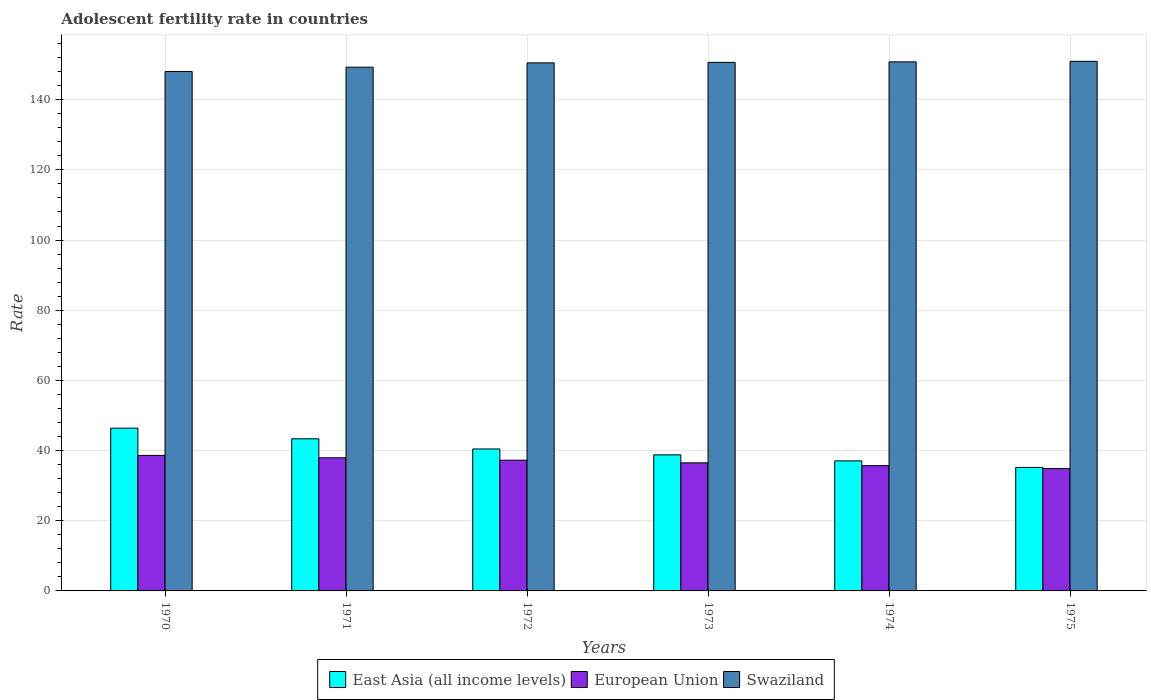How many groups of bars are there?
Keep it short and to the point. 6. Are the number of bars per tick equal to the number of legend labels?
Your answer should be compact. Yes. How many bars are there on the 4th tick from the right?
Your answer should be very brief. 3. What is the label of the 5th group of bars from the left?
Provide a succinct answer. 1974. What is the adolescent fertility rate in European Union in 1973?
Offer a very short reply. 36.5. Across all years, what is the maximum adolescent fertility rate in European Union?
Make the answer very short. 38.62. Across all years, what is the minimum adolescent fertility rate in East Asia (all income levels)?
Give a very brief answer. 35.21. In which year was the adolescent fertility rate in European Union minimum?
Ensure brevity in your answer.  1975. What is the total adolescent fertility rate in European Union in the graph?
Provide a short and direct response. 220.91. What is the difference between the adolescent fertility rate in Swaziland in 1971 and that in 1972?
Offer a very short reply. -1.23. What is the difference between the adolescent fertility rate in East Asia (all income levels) in 1970 and the adolescent fertility rate in European Union in 1971?
Your answer should be very brief. 8.45. What is the average adolescent fertility rate in European Union per year?
Give a very brief answer. 36.82. In the year 1973, what is the difference between the adolescent fertility rate in East Asia (all income levels) and adolescent fertility rate in European Union?
Give a very brief answer. 2.28. In how many years, is the adolescent fertility rate in European Union greater than 112?
Make the answer very short. 0. What is the ratio of the adolescent fertility rate in East Asia (all income levels) in 1970 to that in 1974?
Offer a terse response. 1.25. Is the adolescent fertility rate in Swaziland in 1973 less than that in 1975?
Your response must be concise. Yes. What is the difference between the highest and the second highest adolescent fertility rate in European Union?
Provide a succinct answer. 0.67. What is the difference between the highest and the lowest adolescent fertility rate in East Asia (all income levels)?
Your answer should be compact. 11.19. What does the 1st bar from the left in 1975 represents?
Make the answer very short. East Asia (all income levels). What does the 3rd bar from the right in 1972 represents?
Your response must be concise. East Asia (all income levels). Is it the case that in every year, the sum of the adolescent fertility rate in East Asia (all income levels) and adolescent fertility rate in Swaziland is greater than the adolescent fertility rate in European Union?
Offer a terse response. Yes. How many bars are there?
Provide a short and direct response. 18. What is the difference between two consecutive major ticks on the Y-axis?
Provide a short and direct response. 20. Does the graph contain grids?
Provide a succinct answer. Yes. Where does the legend appear in the graph?
Give a very brief answer. Bottom center. How many legend labels are there?
Provide a short and direct response. 3. What is the title of the graph?
Your answer should be very brief. Adolescent fertility rate in countries. Does "Brazil" appear as one of the legend labels in the graph?
Make the answer very short. No. What is the label or title of the Y-axis?
Provide a short and direct response. Rate. What is the Rate in East Asia (all income levels) in 1970?
Provide a succinct answer. 46.4. What is the Rate of European Union in 1970?
Your answer should be compact. 38.62. What is the Rate in Swaziland in 1970?
Ensure brevity in your answer.  148.05. What is the Rate of East Asia (all income levels) in 1971?
Provide a short and direct response. 43.36. What is the Rate in European Union in 1971?
Your answer should be very brief. 37.94. What is the Rate of Swaziland in 1971?
Make the answer very short. 149.28. What is the Rate of East Asia (all income levels) in 1972?
Give a very brief answer. 40.46. What is the Rate in European Union in 1972?
Provide a short and direct response. 37.26. What is the Rate of Swaziland in 1972?
Keep it short and to the point. 150.5. What is the Rate of East Asia (all income levels) in 1973?
Offer a terse response. 38.78. What is the Rate of European Union in 1973?
Provide a succinct answer. 36.5. What is the Rate of Swaziland in 1973?
Make the answer very short. 150.65. What is the Rate of East Asia (all income levels) in 1974?
Keep it short and to the point. 37.06. What is the Rate in European Union in 1974?
Make the answer very short. 35.71. What is the Rate in Swaziland in 1974?
Keep it short and to the point. 150.79. What is the Rate in East Asia (all income levels) in 1975?
Give a very brief answer. 35.21. What is the Rate of European Union in 1975?
Give a very brief answer. 34.88. What is the Rate of Swaziland in 1975?
Your response must be concise. 150.94. Across all years, what is the maximum Rate in East Asia (all income levels)?
Your response must be concise. 46.4. Across all years, what is the maximum Rate in European Union?
Make the answer very short. 38.62. Across all years, what is the maximum Rate in Swaziland?
Keep it short and to the point. 150.94. Across all years, what is the minimum Rate of East Asia (all income levels)?
Your answer should be very brief. 35.21. Across all years, what is the minimum Rate in European Union?
Ensure brevity in your answer.  34.88. Across all years, what is the minimum Rate of Swaziland?
Your answer should be very brief. 148.05. What is the total Rate of East Asia (all income levels) in the graph?
Give a very brief answer. 241.27. What is the total Rate of European Union in the graph?
Give a very brief answer. 220.91. What is the total Rate in Swaziland in the graph?
Your response must be concise. 900.2. What is the difference between the Rate in East Asia (all income levels) in 1970 and that in 1971?
Your response must be concise. 3.04. What is the difference between the Rate of European Union in 1970 and that in 1971?
Ensure brevity in your answer.  0.67. What is the difference between the Rate of Swaziland in 1970 and that in 1971?
Your answer should be compact. -1.23. What is the difference between the Rate in East Asia (all income levels) in 1970 and that in 1972?
Provide a succinct answer. 5.94. What is the difference between the Rate in European Union in 1970 and that in 1972?
Keep it short and to the point. 1.36. What is the difference between the Rate of Swaziland in 1970 and that in 1972?
Give a very brief answer. -2.46. What is the difference between the Rate of East Asia (all income levels) in 1970 and that in 1973?
Offer a terse response. 7.62. What is the difference between the Rate of European Union in 1970 and that in 1973?
Give a very brief answer. 2.11. What is the difference between the Rate of East Asia (all income levels) in 1970 and that in 1974?
Offer a very short reply. 9.34. What is the difference between the Rate of European Union in 1970 and that in 1974?
Make the answer very short. 2.9. What is the difference between the Rate in Swaziland in 1970 and that in 1974?
Offer a terse response. -2.74. What is the difference between the Rate of East Asia (all income levels) in 1970 and that in 1975?
Keep it short and to the point. 11.19. What is the difference between the Rate of European Union in 1970 and that in 1975?
Provide a succinct answer. 3.74. What is the difference between the Rate of Swaziland in 1970 and that in 1975?
Give a very brief answer. -2.89. What is the difference between the Rate in East Asia (all income levels) in 1971 and that in 1972?
Make the answer very short. 2.9. What is the difference between the Rate in European Union in 1971 and that in 1972?
Offer a terse response. 0.69. What is the difference between the Rate in Swaziland in 1971 and that in 1972?
Offer a very short reply. -1.23. What is the difference between the Rate of East Asia (all income levels) in 1971 and that in 1973?
Your answer should be very brief. 4.58. What is the difference between the Rate of European Union in 1971 and that in 1973?
Offer a very short reply. 1.44. What is the difference between the Rate of Swaziland in 1971 and that in 1973?
Make the answer very short. -1.37. What is the difference between the Rate in East Asia (all income levels) in 1971 and that in 1974?
Provide a succinct answer. 6.3. What is the difference between the Rate in European Union in 1971 and that in 1974?
Keep it short and to the point. 2.23. What is the difference between the Rate of Swaziland in 1971 and that in 1974?
Ensure brevity in your answer.  -1.52. What is the difference between the Rate in East Asia (all income levels) in 1971 and that in 1975?
Your answer should be compact. 8.15. What is the difference between the Rate in European Union in 1971 and that in 1975?
Provide a succinct answer. 3.06. What is the difference between the Rate in Swaziland in 1971 and that in 1975?
Give a very brief answer. -1.66. What is the difference between the Rate in East Asia (all income levels) in 1972 and that in 1973?
Keep it short and to the point. 1.68. What is the difference between the Rate in European Union in 1972 and that in 1973?
Make the answer very short. 0.75. What is the difference between the Rate of Swaziland in 1972 and that in 1973?
Ensure brevity in your answer.  -0.14. What is the difference between the Rate in East Asia (all income levels) in 1972 and that in 1974?
Your response must be concise. 3.4. What is the difference between the Rate in European Union in 1972 and that in 1974?
Offer a very short reply. 1.54. What is the difference between the Rate of Swaziland in 1972 and that in 1974?
Offer a very short reply. -0.29. What is the difference between the Rate in East Asia (all income levels) in 1972 and that in 1975?
Provide a succinct answer. 5.25. What is the difference between the Rate of European Union in 1972 and that in 1975?
Offer a very short reply. 2.38. What is the difference between the Rate of Swaziland in 1972 and that in 1975?
Make the answer very short. -0.43. What is the difference between the Rate of East Asia (all income levels) in 1973 and that in 1974?
Offer a terse response. 1.72. What is the difference between the Rate in European Union in 1973 and that in 1974?
Your answer should be compact. 0.79. What is the difference between the Rate in Swaziland in 1973 and that in 1974?
Make the answer very short. -0.14. What is the difference between the Rate in East Asia (all income levels) in 1973 and that in 1975?
Offer a very short reply. 3.57. What is the difference between the Rate in European Union in 1973 and that in 1975?
Offer a terse response. 1.62. What is the difference between the Rate in Swaziland in 1973 and that in 1975?
Provide a succinct answer. -0.29. What is the difference between the Rate in East Asia (all income levels) in 1974 and that in 1975?
Ensure brevity in your answer.  1.85. What is the difference between the Rate of European Union in 1974 and that in 1975?
Give a very brief answer. 0.83. What is the difference between the Rate in Swaziland in 1974 and that in 1975?
Your answer should be very brief. -0.14. What is the difference between the Rate of East Asia (all income levels) in 1970 and the Rate of European Union in 1971?
Your answer should be very brief. 8.45. What is the difference between the Rate of East Asia (all income levels) in 1970 and the Rate of Swaziland in 1971?
Keep it short and to the point. -102.88. What is the difference between the Rate of European Union in 1970 and the Rate of Swaziland in 1971?
Make the answer very short. -110.66. What is the difference between the Rate of East Asia (all income levels) in 1970 and the Rate of European Union in 1972?
Your answer should be very brief. 9.14. What is the difference between the Rate in East Asia (all income levels) in 1970 and the Rate in Swaziland in 1972?
Your response must be concise. -104.1. What is the difference between the Rate of European Union in 1970 and the Rate of Swaziland in 1972?
Give a very brief answer. -111.89. What is the difference between the Rate of East Asia (all income levels) in 1970 and the Rate of European Union in 1973?
Your answer should be very brief. 9.9. What is the difference between the Rate in East Asia (all income levels) in 1970 and the Rate in Swaziland in 1973?
Offer a very short reply. -104.25. What is the difference between the Rate in European Union in 1970 and the Rate in Swaziland in 1973?
Ensure brevity in your answer.  -112.03. What is the difference between the Rate of East Asia (all income levels) in 1970 and the Rate of European Union in 1974?
Your response must be concise. 10.69. What is the difference between the Rate of East Asia (all income levels) in 1970 and the Rate of Swaziland in 1974?
Offer a very short reply. -104.39. What is the difference between the Rate in European Union in 1970 and the Rate in Swaziland in 1974?
Ensure brevity in your answer.  -112.18. What is the difference between the Rate of East Asia (all income levels) in 1970 and the Rate of European Union in 1975?
Your answer should be very brief. 11.52. What is the difference between the Rate of East Asia (all income levels) in 1970 and the Rate of Swaziland in 1975?
Offer a terse response. -104.54. What is the difference between the Rate of European Union in 1970 and the Rate of Swaziland in 1975?
Provide a short and direct response. -112.32. What is the difference between the Rate of East Asia (all income levels) in 1971 and the Rate of European Union in 1972?
Give a very brief answer. 6.11. What is the difference between the Rate in East Asia (all income levels) in 1971 and the Rate in Swaziland in 1972?
Your answer should be very brief. -107.14. What is the difference between the Rate of European Union in 1971 and the Rate of Swaziland in 1972?
Provide a short and direct response. -112.56. What is the difference between the Rate of East Asia (all income levels) in 1971 and the Rate of European Union in 1973?
Offer a very short reply. 6.86. What is the difference between the Rate of East Asia (all income levels) in 1971 and the Rate of Swaziland in 1973?
Your answer should be very brief. -107.28. What is the difference between the Rate of European Union in 1971 and the Rate of Swaziland in 1973?
Make the answer very short. -112.7. What is the difference between the Rate in East Asia (all income levels) in 1971 and the Rate in European Union in 1974?
Ensure brevity in your answer.  7.65. What is the difference between the Rate in East Asia (all income levels) in 1971 and the Rate in Swaziland in 1974?
Your answer should be very brief. -107.43. What is the difference between the Rate in European Union in 1971 and the Rate in Swaziland in 1974?
Provide a short and direct response. -112.85. What is the difference between the Rate in East Asia (all income levels) in 1971 and the Rate in European Union in 1975?
Keep it short and to the point. 8.48. What is the difference between the Rate of East Asia (all income levels) in 1971 and the Rate of Swaziland in 1975?
Make the answer very short. -107.57. What is the difference between the Rate in European Union in 1971 and the Rate in Swaziland in 1975?
Offer a terse response. -112.99. What is the difference between the Rate of East Asia (all income levels) in 1972 and the Rate of European Union in 1973?
Make the answer very short. 3.96. What is the difference between the Rate of East Asia (all income levels) in 1972 and the Rate of Swaziland in 1973?
Provide a short and direct response. -110.19. What is the difference between the Rate in European Union in 1972 and the Rate in Swaziland in 1973?
Provide a short and direct response. -113.39. What is the difference between the Rate of East Asia (all income levels) in 1972 and the Rate of European Union in 1974?
Ensure brevity in your answer.  4.75. What is the difference between the Rate in East Asia (all income levels) in 1972 and the Rate in Swaziland in 1974?
Your answer should be very brief. -110.33. What is the difference between the Rate in European Union in 1972 and the Rate in Swaziland in 1974?
Your answer should be compact. -113.54. What is the difference between the Rate in East Asia (all income levels) in 1972 and the Rate in European Union in 1975?
Ensure brevity in your answer.  5.58. What is the difference between the Rate in East Asia (all income levels) in 1972 and the Rate in Swaziland in 1975?
Provide a succinct answer. -110.48. What is the difference between the Rate of European Union in 1972 and the Rate of Swaziland in 1975?
Provide a succinct answer. -113.68. What is the difference between the Rate in East Asia (all income levels) in 1973 and the Rate in European Union in 1974?
Provide a short and direct response. 3.07. What is the difference between the Rate of East Asia (all income levels) in 1973 and the Rate of Swaziland in 1974?
Give a very brief answer. -112.01. What is the difference between the Rate of European Union in 1973 and the Rate of Swaziland in 1974?
Your answer should be compact. -114.29. What is the difference between the Rate in East Asia (all income levels) in 1973 and the Rate in European Union in 1975?
Make the answer very short. 3.9. What is the difference between the Rate in East Asia (all income levels) in 1973 and the Rate in Swaziland in 1975?
Offer a very short reply. -112.16. What is the difference between the Rate of European Union in 1973 and the Rate of Swaziland in 1975?
Your response must be concise. -114.43. What is the difference between the Rate in East Asia (all income levels) in 1974 and the Rate in European Union in 1975?
Make the answer very short. 2.18. What is the difference between the Rate of East Asia (all income levels) in 1974 and the Rate of Swaziland in 1975?
Your answer should be very brief. -113.88. What is the difference between the Rate in European Union in 1974 and the Rate in Swaziland in 1975?
Make the answer very short. -115.22. What is the average Rate in East Asia (all income levels) per year?
Offer a terse response. 40.21. What is the average Rate in European Union per year?
Offer a very short reply. 36.82. What is the average Rate in Swaziland per year?
Your answer should be compact. 150.03. In the year 1970, what is the difference between the Rate in East Asia (all income levels) and Rate in European Union?
Offer a terse response. 7.78. In the year 1970, what is the difference between the Rate of East Asia (all income levels) and Rate of Swaziland?
Your response must be concise. -101.65. In the year 1970, what is the difference between the Rate of European Union and Rate of Swaziland?
Give a very brief answer. -109.43. In the year 1971, what is the difference between the Rate in East Asia (all income levels) and Rate in European Union?
Your response must be concise. 5.42. In the year 1971, what is the difference between the Rate in East Asia (all income levels) and Rate in Swaziland?
Offer a very short reply. -105.91. In the year 1971, what is the difference between the Rate of European Union and Rate of Swaziland?
Provide a succinct answer. -111.33. In the year 1972, what is the difference between the Rate in East Asia (all income levels) and Rate in European Union?
Your answer should be very brief. 3.2. In the year 1972, what is the difference between the Rate in East Asia (all income levels) and Rate in Swaziland?
Ensure brevity in your answer.  -110.04. In the year 1972, what is the difference between the Rate in European Union and Rate in Swaziland?
Make the answer very short. -113.25. In the year 1973, what is the difference between the Rate of East Asia (all income levels) and Rate of European Union?
Offer a very short reply. 2.28. In the year 1973, what is the difference between the Rate in East Asia (all income levels) and Rate in Swaziland?
Make the answer very short. -111.87. In the year 1973, what is the difference between the Rate of European Union and Rate of Swaziland?
Give a very brief answer. -114.14. In the year 1974, what is the difference between the Rate of East Asia (all income levels) and Rate of European Union?
Keep it short and to the point. 1.35. In the year 1974, what is the difference between the Rate in East Asia (all income levels) and Rate in Swaziland?
Your answer should be compact. -113.73. In the year 1974, what is the difference between the Rate in European Union and Rate in Swaziland?
Your response must be concise. -115.08. In the year 1975, what is the difference between the Rate in East Asia (all income levels) and Rate in European Union?
Give a very brief answer. 0.33. In the year 1975, what is the difference between the Rate of East Asia (all income levels) and Rate of Swaziland?
Offer a terse response. -115.73. In the year 1975, what is the difference between the Rate in European Union and Rate in Swaziland?
Give a very brief answer. -116.06. What is the ratio of the Rate of East Asia (all income levels) in 1970 to that in 1971?
Offer a terse response. 1.07. What is the ratio of the Rate of European Union in 1970 to that in 1971?
Your answer should be compact. 1.02. What is the ratio of the Rate of Swaziland in 1970 to that in 1971?
Ensure brevity in your answer.  0.99. What is the ratio of the Rate in East Asia (all income levels) in 1970 to that in 1972?
Ensure brevity in your answer.  1.15. What is the ratio of the Rate of European Union in 1970 to that in 1972?
Ensure brevity in your answer.  1.04. What is the ratio of the Rate in Swaziland in 1970 to that in 1972?
Provide a succinct answer. 0.98. What is the ratio of the Rate of East Asia (all income levels) in 1970 to that in 1973?
Your answer should be compact. 1.2. What is the ratio of the Rate in European Union in 1970 to that in 1973?
Offer a very short reply. 1.06. What is the ratio of the Rate of Swaziland in 1970 to that in 1973?
Your answer should be compact. 0.98. What is the ratio of the Rate in East Asia (all income levels) in 1970 to that in 1974?
Give a very brief answer. 1.25. What is the ratio of the Rate in European Union in 1970 to that in 1974?
Give a very brief answer. 1.08. What is the ratio of the Rate of Swaziland in 1970 to that in 1974?
Ensure brevity in your answer.  0.98. What is the ratio of the Rate in East Asia (all income levels) in 1970 to that in 1975?
Give a very brief answer. 1.32. What is the ratio of the Rate of European Union in 1970 to that in 1975?
Make the answer very short. 1.11. What is the ratio of the Rate of Swaziland in 1970 to that in 1975?
Make the answer very short. 0.98. What is the ratio of the Rate in East Asia (all income levels) in 1971 to that in 1972?
Offer a very short reply. 1.07. What is the ratio of the Rate of European Union in 1971 to that in 1972?
Provide a short and direct response. 1.02. What is the ratio of the Rate of Swaziland in 1971 to that in 1972?
Offer a terse response. 0.99. What is the ratio of the Rate of East Asia (all income levels) in 1971 to that in 1973?
Your answer should be compact. 1.12. What is the ratio of the Rate of European Union in 1971 to that in 1973?
Provide a short and direct response. 1.04. What is the ratio of the Rate of Swaziland in 1971 to that in 1973?
Keep it short and to the point. 0.99. What is the ratio of the Rate in East Asia (all income levels) in 1971 to that in 1974?
Provide a succinct answer. 1.17. What is the ratio of the Rate in European Union in 1971 to that in 1974?
Your answer should be very brief. 1.06. What is the ratio of the Rate in East Asia (all income levels) in 1971 to that in 1975?
Ensure brevity in your answer.  1.23. What is the ratio of the Rate in European Union in 1971 to that in 1975?
Give a very brief answer. 1.09. What is the ratio of the Rate in East Asia (all income levels) in 1972 to that in 1973?
Your answer should be very brief. 1.04. What is the ratio of the Rate in European Union in 1972 to that in 1973?
Your answer should be compact. 1.02. What is the ratio of the Rate of East Asia (all income levels) in 1972 to that in 1974?
Make the answer very short. 1.09. What is the ratio of the Rate of European Union in 1972 to that in 1974?
Offer a terse response. 1.04. What is the ratio of the Rate in Swaziland in 1972 to that in 1974?
Offer a very short reply. 1. What is the ratio of the Rate of East Asia (all income levels) in 1972 to that in 1975?
Ensure brevity in your answer.  1.15. What is the ratio of the Rate of European Union in 1972 to that in 1975?
Ensure brevity in your answer.  1.07. What is the ratio of the Rate of Swaziland in 1972 to that in 1975?
Make the answer very short. 1. What is the ratio of the Rate in East Asia (all income levels) in 1973 to that in 1974?
Your answer should be very brief. 1.05. What is the ratio of the Rate in European Union in 1973 to that in 1974?
Give a very brief answer. 1.02. What is the ratio of the Rate in Swaziland in 1973 to that in 1974?
Ensure brevity in your answer.  1. What is the ratio of the Rate in East Asia (all income levels) in 1973 to that in 1975?
Provide a succinct answer. 1.1. What is the ratio of the Rate in European Union in 1973 to that in 1975?
Your answer should be compact. 1.05. What is the ratio of the Rate in East Asia (all income levels) in 1974 to that in 1975?
Provide a short and direct response. 1.05. What is the ratio of the Rate of European Union in 1974 to that in 1975?
Your answer should be very brief. 1.02. What is the difference between the highest and the second highest Rate in East Asia (all income levels)?
Your answer should be very brief. 3.04. What is the difference between the highest and the second highest Rate of European Union?
Offer a very short reply. 0.67. What is the difference between the highest and the second highest Rate in Swaziland?
Your answer should be very brief. 0.14. What is the difference between the highest and the lowest Rate in East Asia (all income levels)?
Provide a short and direct response. 11.19. What is the difference between the highest and the lowest Rate in European Union?
Keep it short and to the point. 3.74. What is the difference between the highest and the lowest Rate in Swaziland?
Your answer should be very brief. 2.89. 